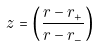Convert formula to latex. <formula><loc_0><loc_0><loc_500><loc_500>z = \left ( \frac { r - r _ { + } } { r - r _ { - } } \right )</formula> 